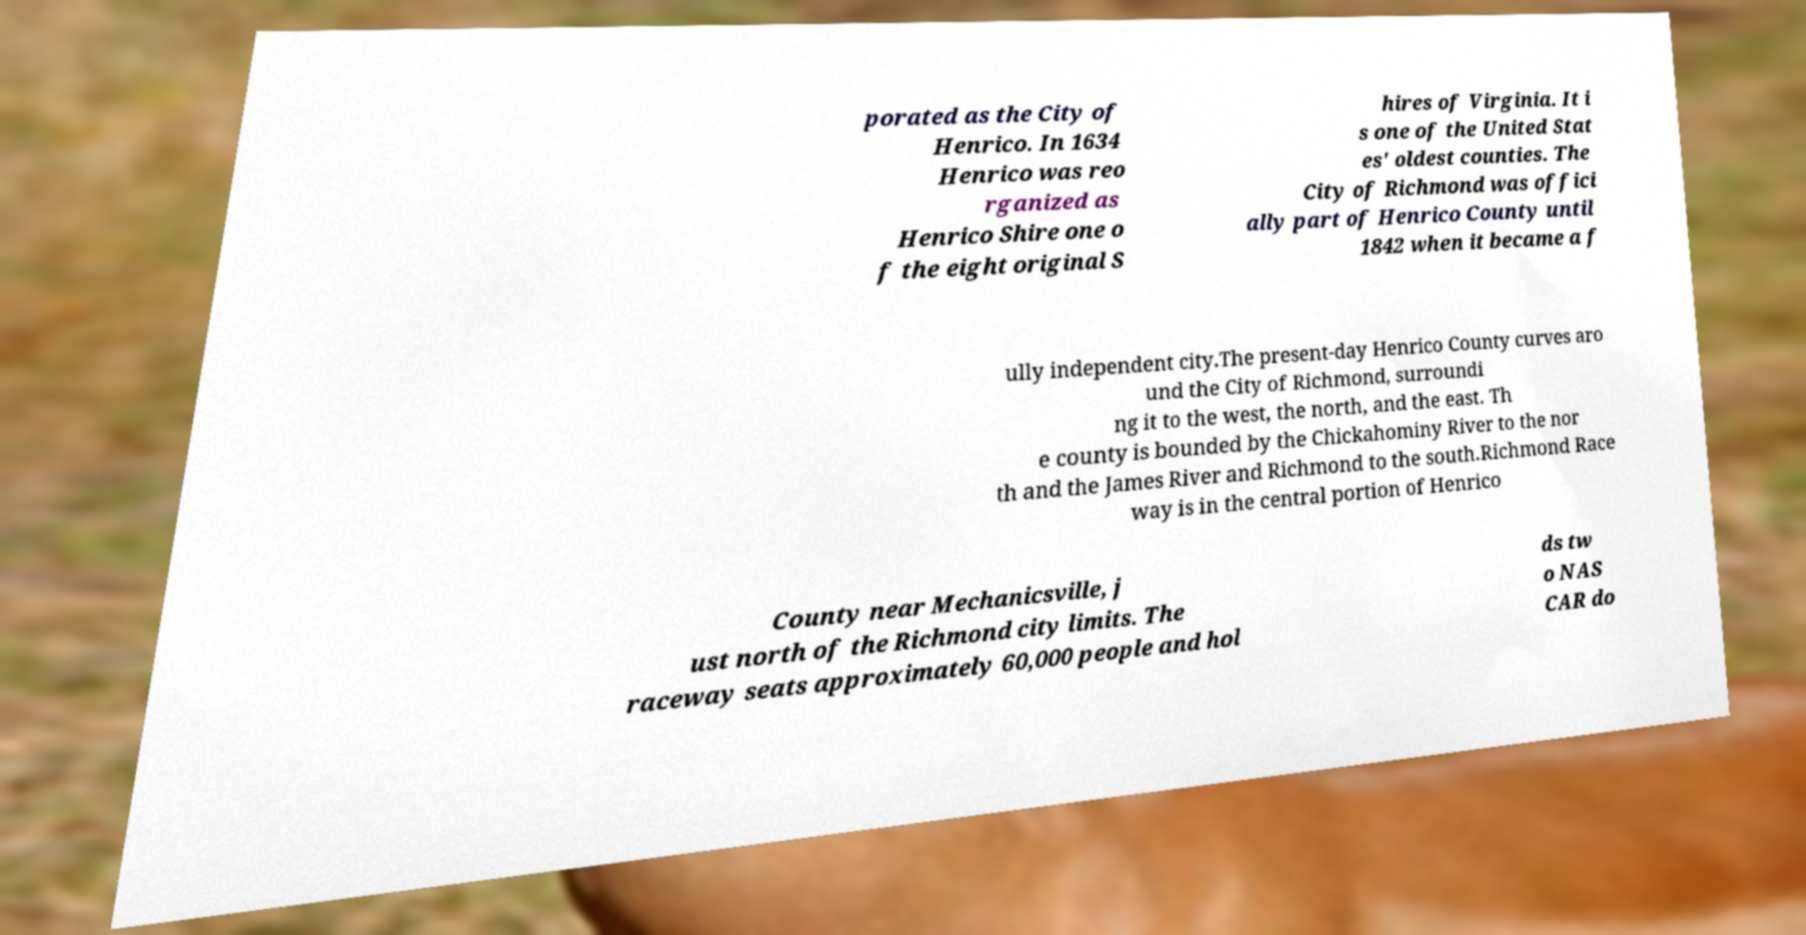There's text embedded in this image that I need extracted. Can you transcribe it verbatim? porated as the City of Henrico. In 1634 Henrico was reo rganized as Henrico Shire one o f the eight original S hires of Virginia. It i s one of the United Stat es' oldest counties. The City of Richmond was offici ally part of Henrico County until 1842 when it became a f ully independent city.The present-day Henrico County curves aro und the City of Richmond, surroundi ng it to the west, the north, and the east. Th e county is bounded by the Chickahominy River to the nor th and the James River and Richmond to the south.Richmond Race way is in the central portion of Henrico County near Mechanicsville, j ust north of the Richmond city limits. The raceway seats approximately 60,000 people and hol ds tw o NAS CAR do 